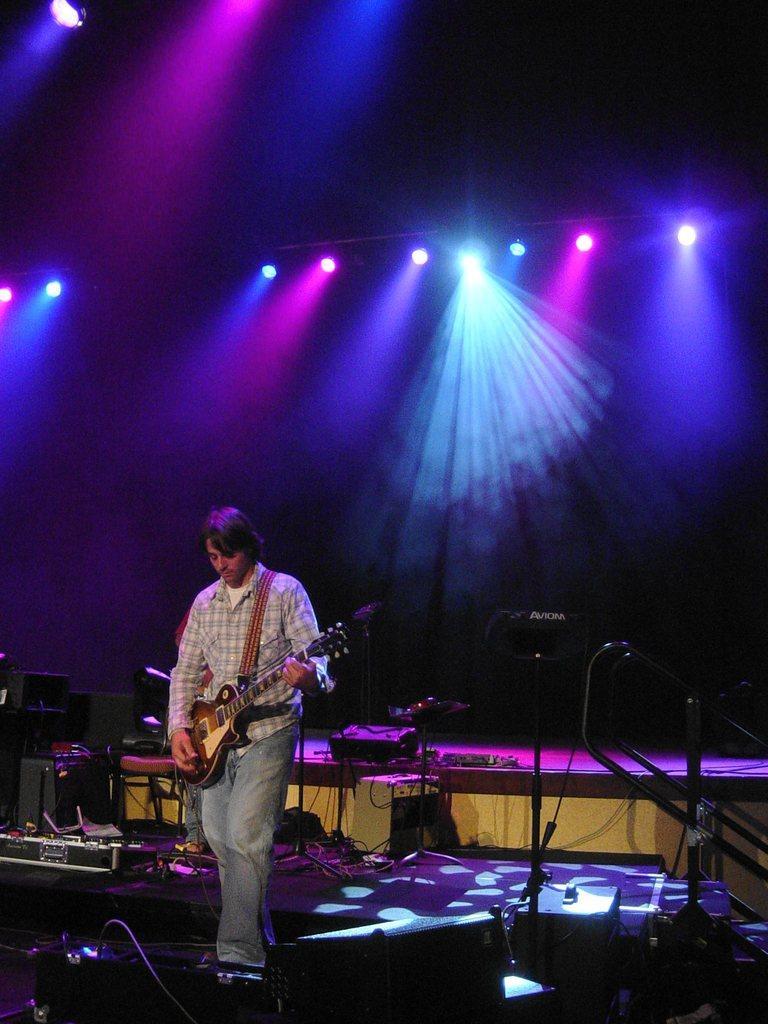Can you describe this image briefly? This image is clicked in a musical concert. There are lights on the top. There are so many musical instruments in the middle. In the middle there is a man who is playing guitar. There are mike's. 